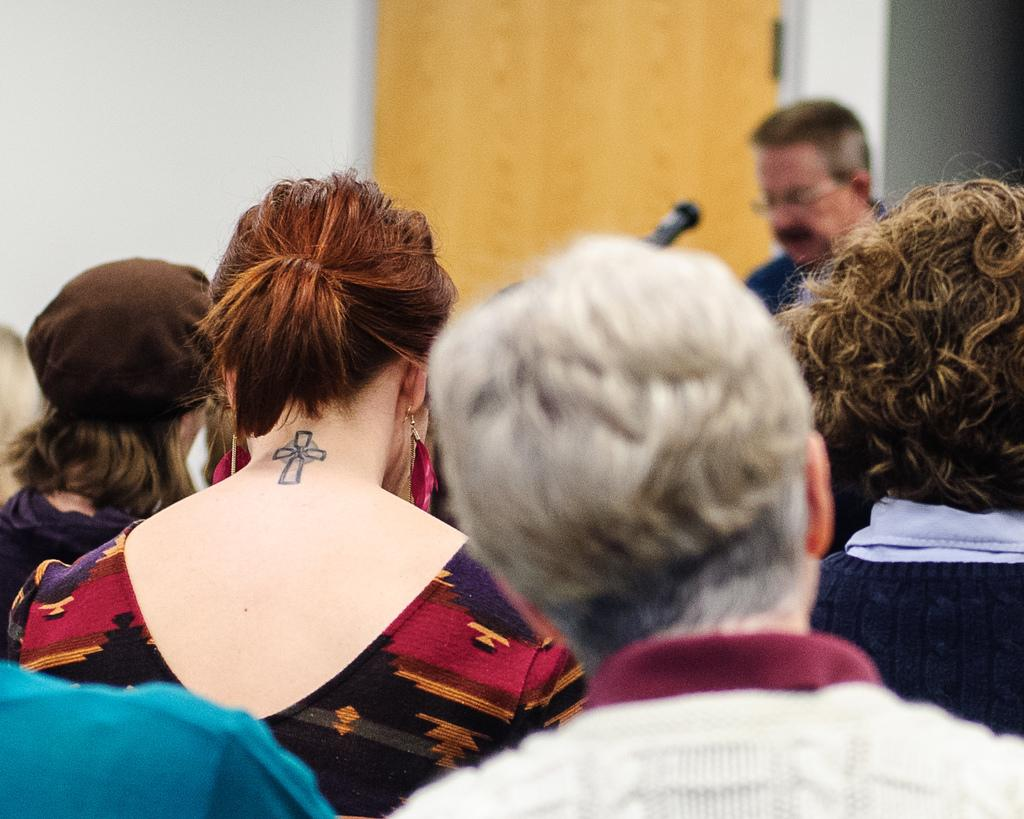How many people are in the image? There is a group of people in the image, but the exact number cannot be determined from the provided facts. What object is present that might be used for amplifying sound? There is a microphone in the image. What type of structure can be seen in the image? There is a wall in the image. Is there an entrance or exit visible in the image? There appears to be a door in the image. What type of volleyball game is being played in the image? There is no volleyball game present in the image. What type of fowl can be seen in the image? There is no fowl present in the image. 